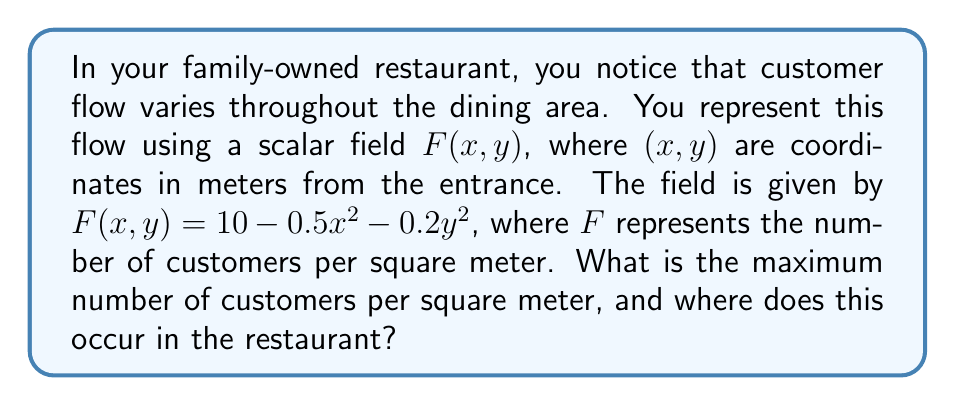Give your solution to this math problem. To find the maximum value of the scalar field and its location, we need to follow these steps:

1) The scalar field is given by $F(x,y) = 10 - 0.5x^2 - 0.2y^2$

2) To find the maximum, we need to find the critical points by taking partial derivatives and setting them to zero:

   $\frac{\partial F}{\partial x} = -x = 0$
   $\frac{\partial F}{\partial y} = -0.4y = 0$

3) Solving these equations:
   $x = 0$ and $y = 0$

4) The critical point is at $(0,0)$, which represents the entrance of the restaurant.

5) To confirm this is a maximum, we can check the second derivatives:

   $\frac{\partial^2 F}{\partial x^2} = -1 < 0$
   $\frac{\partial^2 F}{\partial y^2} = -0.4 < 0$

   Both are negative, confirming a maximum.

6) To find the maximum value, we substitute $(0,0)$ into the original function:

   $F(0,0) = 10 - 0.5(0)^2 - 0.2(0)^2 = 10$

Therefore, the maximum number of customers per square meter is 10, occurring at the entrance (0,0).
Answer: 10 customers/m², at (0,0) 